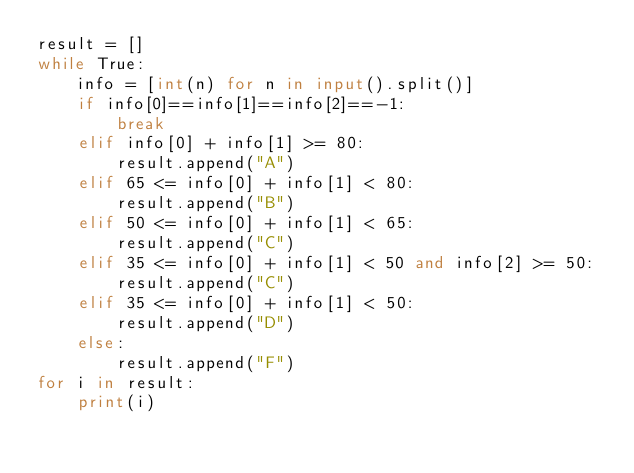Convert code to text. <code><loc_0><loc_0><loc_500><loc_500><_Python_>result = []
while True:
    info = [int(n) for n in input().split()]
    if info[0]==info[1]==info[2]==-1:
        break
    elif info[0] + info[1] >= 80:
        result.append("A")
    elif 65 <= info[0] + info[1] < 80:
        result.append("B")
    elif 50 <= info[0] + info[1] < 65:
        result.append("C")
    elif 35 <= info[0] + info[1] < 50 and info[2] >= 50:
        result.append("C")
    elif 35 <= info[0] + info[1] < 50:
        result.append("D")
    else:
        result.append("F")
for i in result:
    print(i)
</code> 